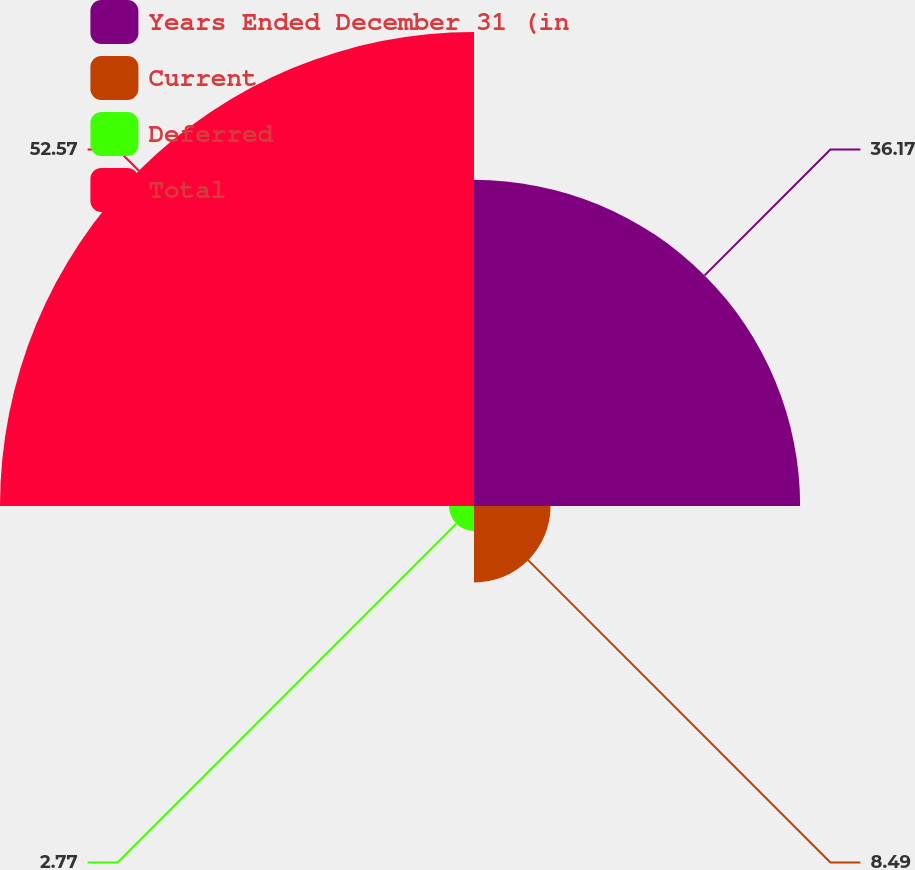Convert chart. <chart><loc_0><loc_0><loc_500><loc_500><pie_chart><fcel>Years Ended December 31 (in<fcel>Current<fcel>Deferred<fcel>Total<nl><fcel>36.17%<fcel>8.49%<fcel>2.77%<fcel>52.57%<nl></chart> 